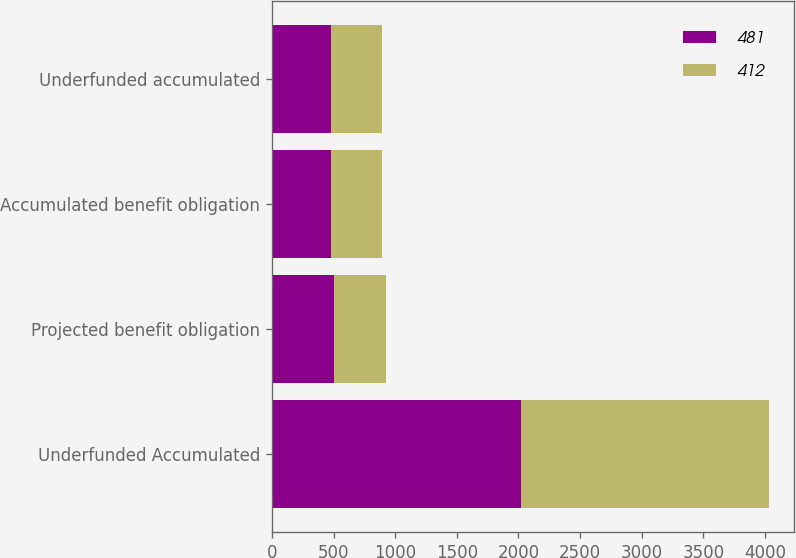Convert chart. <chart><loc_0><loc_0><loc_500><loc_500><stacked_bar_chart><ecel><fcel>Underfunded Accumulated<fcel>Projected benefit obligation<fcel>Accumulated benefit obligation<fcel>Underfunded accumulated<nl><fcel>481<fcel>2017<fcel>501<fcel>481<fcel>481<nl><fcel>412<fcel>2016<fcel>428<fcel>412<fcel>412<nl></chart> 